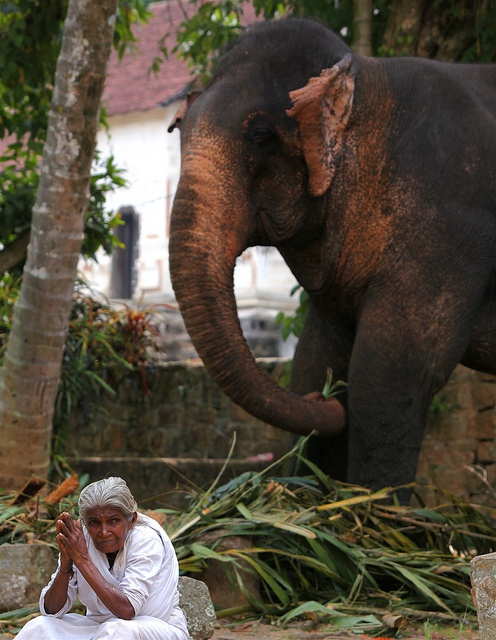Describe the objects in this image and their specific colors. I can see elephant in darkgreen, black, maroon, and gray tones and people in darkgreen, lavender, maroon, darkgray, and gray tones in this image. 